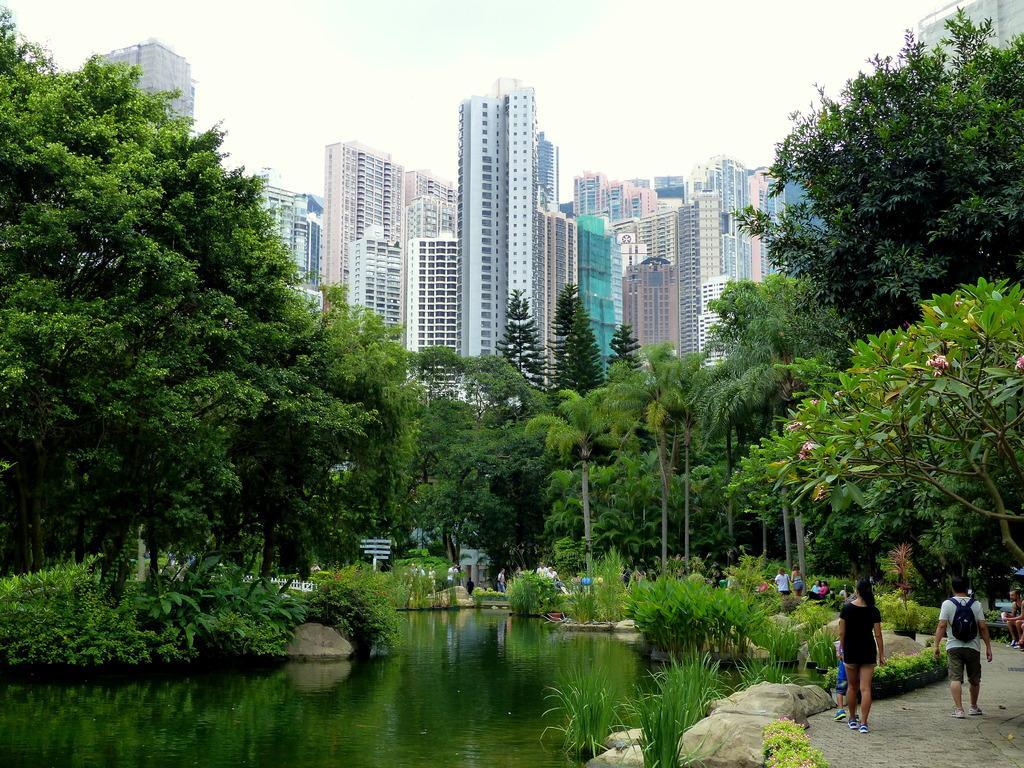Describe this image in one or two sentences. In the picture we can see these people are walking on the way, we can see rocks, grass, plants, water, trees, fence, tower buildings and the sky in the background. 